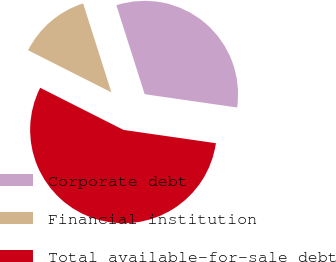Convert chart. <chart><loc_0><loc_0><loc_500><loc_500><pie_chart><fcel>Corporate debt<fcel>Financial institution<fcel>Total available-for-sale debt<nl><fcel>32.18%<fcel>12.64%<fcel>55.17%<nl></chart> 